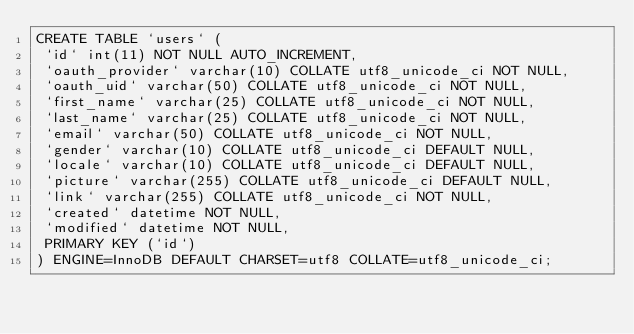<code> <loc_0><loc_0><loc_500><loc_500><_SQL_>CREATE TABLE `users` (
 `id` int(11) NOT NULL AUTO_INCREMENT,
 `oauth_provider` varchar(10) COLLATE utf8_unicode_ci NOT NULL,
 `oauth_uid` varchar(50) COLLATE utf8_unicode_ci NOT NULL,
 `first_name` varchar(25) COLLATE utf8_unicode_ci NOT NULL,
 `last_name` varchar(25) COLLATE utf8_unicode_ci NOT NULL,
 `email` varchar(50) COLLATE utf8_unicode_ci NOT NULL,
 `gender` varchar(10) COLLATE utf8_unicode_ci DEFAULT NULL,
 `locale` varchar(10) COLLATE utf8_unicode_ci DEFAULT NULL,
 `picture` varchar(255) COLLATE utf8_unicode_ci DEFAULT NULL,
 `link` varchar(255) COLLATE utf8_unicode_ci NOT NULL,
 `created` datetime NOT NULL,
 `modified` datetime NOT NULL,
 PRIMARY KEY (`id`)
) ENGINE=InnoDB DEFAULT CHARSET=utf8 COLLATE=utf8_unicode_ci;
</code> 